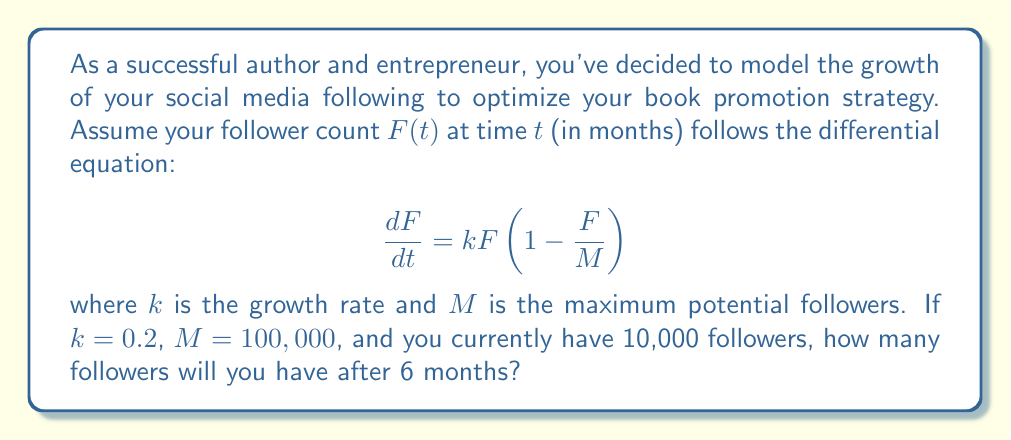Teach me how to tackle this problem. To solve this problem, we need to use the logistic growth model, which is described by the given differential equation. Let's approach this step-by-step:

1) The differential equation is:

   $$\frac{dF}{dt} = kF(1-\frac{F}{M})$$

2) The solution to this equation is the logistic function:

   $$F(t) = \frac{M}{1 + (\frac{M}{F_0} - 1)e^{-kt}}$$

   where $F_0$ is the initial number of followers.

3) We're given:
   - $k = 0.2$ (growth rate)
   - $M = 100,000$ (maximum potential followers)
   - $F_0 = 10,000$ (initial followers)
   - $t = 6$ (time in months)

4) Let's substitute these values into the equation:

   $$F(6) = \frac{100,000}{1 + (\frac{100,000}{10,000} - 1)e^{-0.2(6)}}$$

5) Simplify:

   $$F(6) = \frac{100,000}{1 + (9)e^{-1.2}}$$

6) Calculate:
   $e^{-1.2} \approx 0.301194$
   $9 * 0.301194 \approx 2.710746$

   $$F(6) = \frac{100,000}{1 + 2.710746} \approx 26,950.73$$

7) Round to the nearest whole number:

   $F(6) \approx 26,951$ followers
Answer: 26,951 followers 